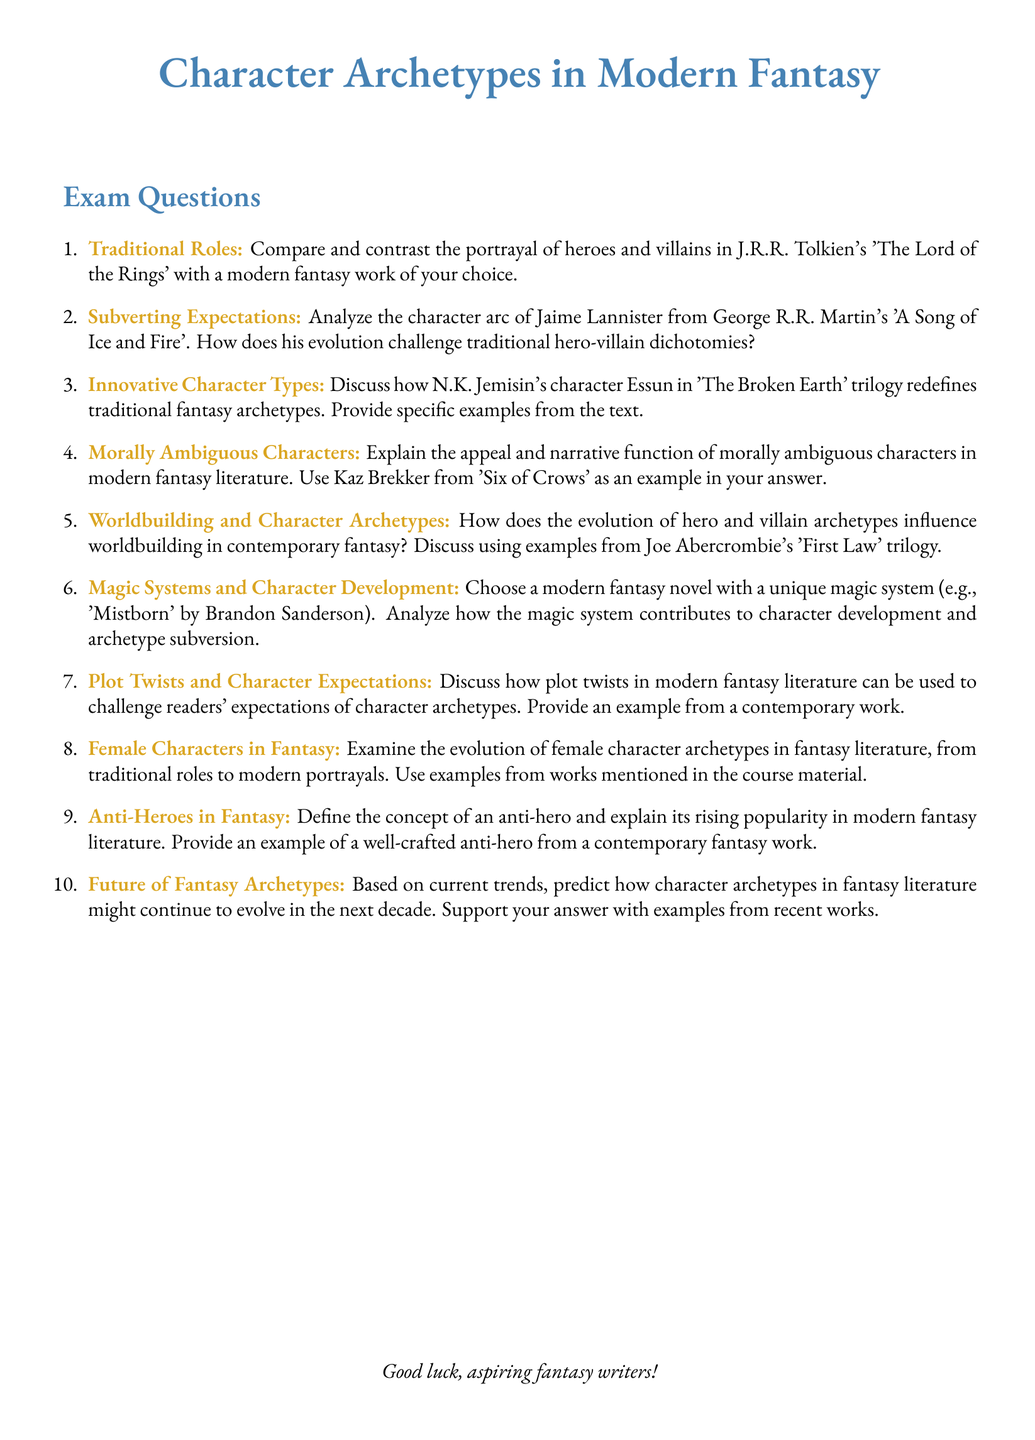What is the title of the exam? The title of the exam is presented at the beginning of the document centered and in a larger font.
Answer: Character Archetypes in Modern Fantasy How many exam questions are there? The number of exam questions is counted in the enumerated list provided.
Answer: Ten What color is used for the section titles? The document specifies the color used for section titles in the formatting commands.
Answer: Mystical blue Who wrote 'A Song of Ice and Fire'? The document mentions the author of 'A Song of Ice and Fire' in the context of character analysis.
Answer: George R.R. Martin Which character is used as an example for morally ambiguous characters? The document explicitly names a character as an example in the relevant question.
Answer: Kaz Brekker What trilogy features the character Essun? The document identifies the work associated with the character Essun when discussing innovative character types.
Answer: The Broken Earth What is the focus of the last question in the exam? The last question's theme can be identified by its phrasing and subject matter.
Answer: Future of Fantasy Archetypes What example is given for unique magic systems? The document provides a specific modern fantasy novel as an example of unique magic systems.
Answer: Mistborn What literary device is mentioned in the context of plot twists? The document discusses a specific literary device related to challenging character expectations.
Answer: Plot twists Which character archetype is defined in the ninth question? The document includes a definition of a specific archetype in the context of contemporary fantasy works.
Answer: Anti-hero 